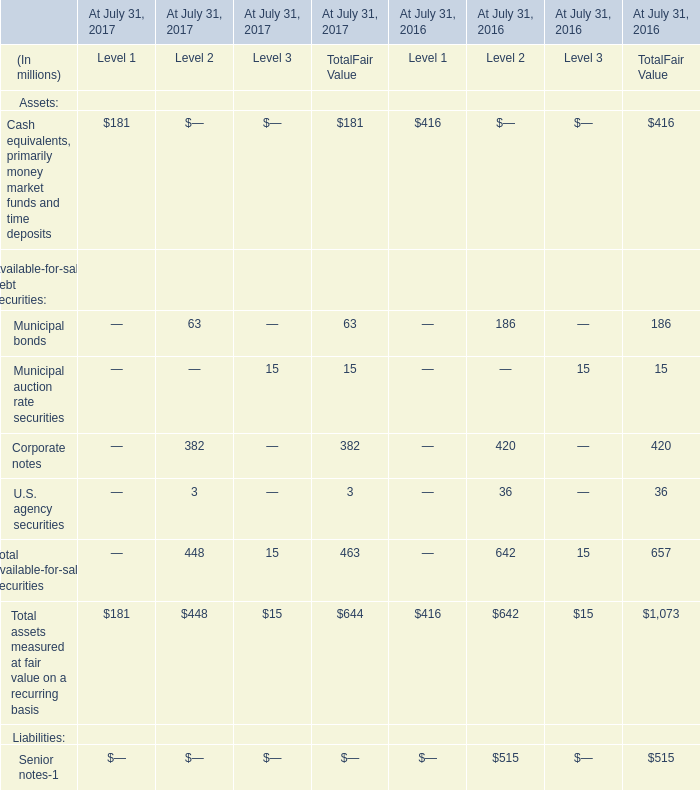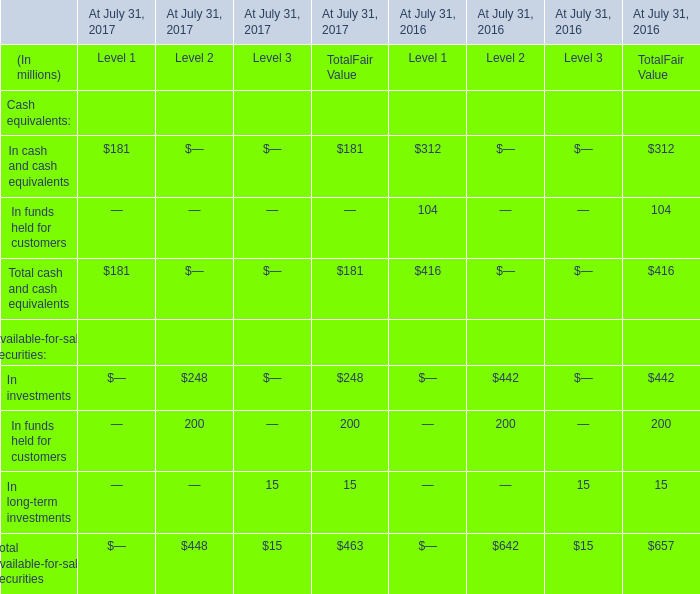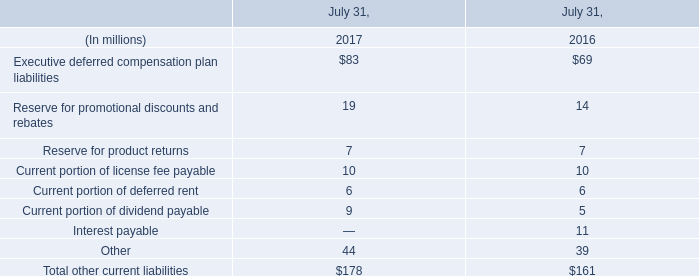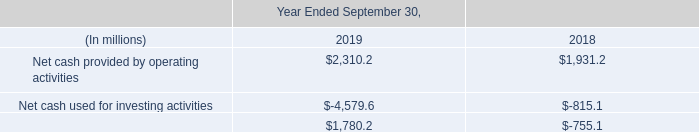What is the sum of TotalFair Value in the range of 0 and 100 in 2017? (in million) 
Computations: ((63 + 15) + 3)
Answer: 81.0. 